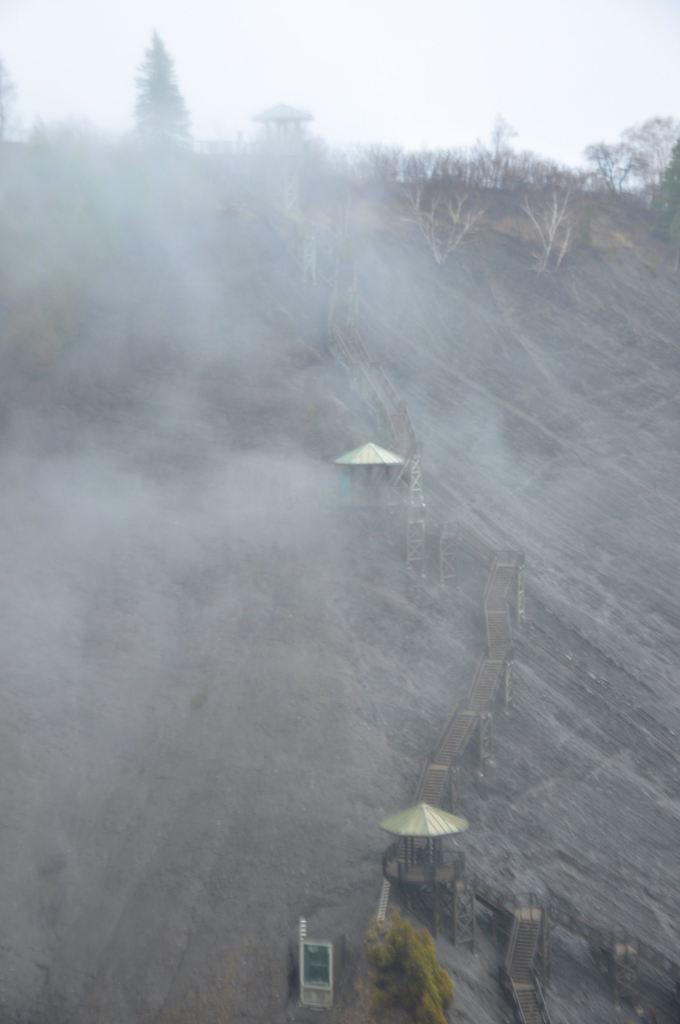What is the general atmosphere or condition of the environment in the image? The image appears to depict a foggy environment. What structures can be seen in the image? There are shelters in the image. What type of pathway is visible in the image? There is a wooden pathway in the image. What type of vegetation is present in the image? Trees are present in the image. What is visible at the top of the image? The sky is visible at the top of the image. What type of glue is being used to hold the cabbage together in the image? There is no cabbage or glue present in the image. Can you tell me what your dad is doing in the image? There is no person, including a dad, present in the image. 